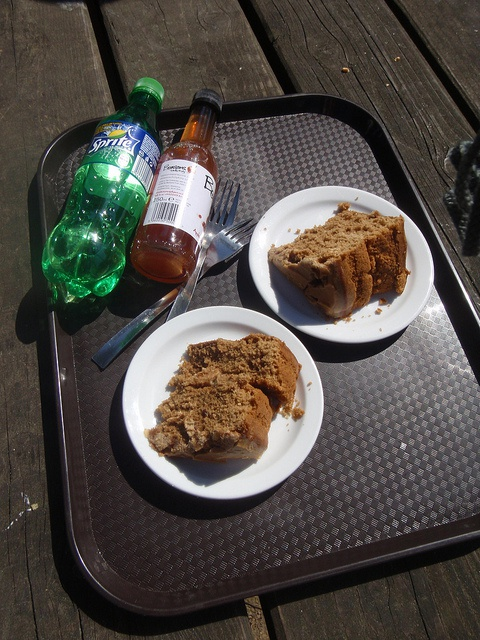Describe the objects in this image and their specific colors. I can see bottle in black, darkgreen, and white tones, cake in black, brown, maroon, and gray tones, cake in black, maroon, brown, and tan tones, cake in black, maroon, brown, and tan tones, and bottle in black, maroon, lavender, and darkgray tones in this image. 